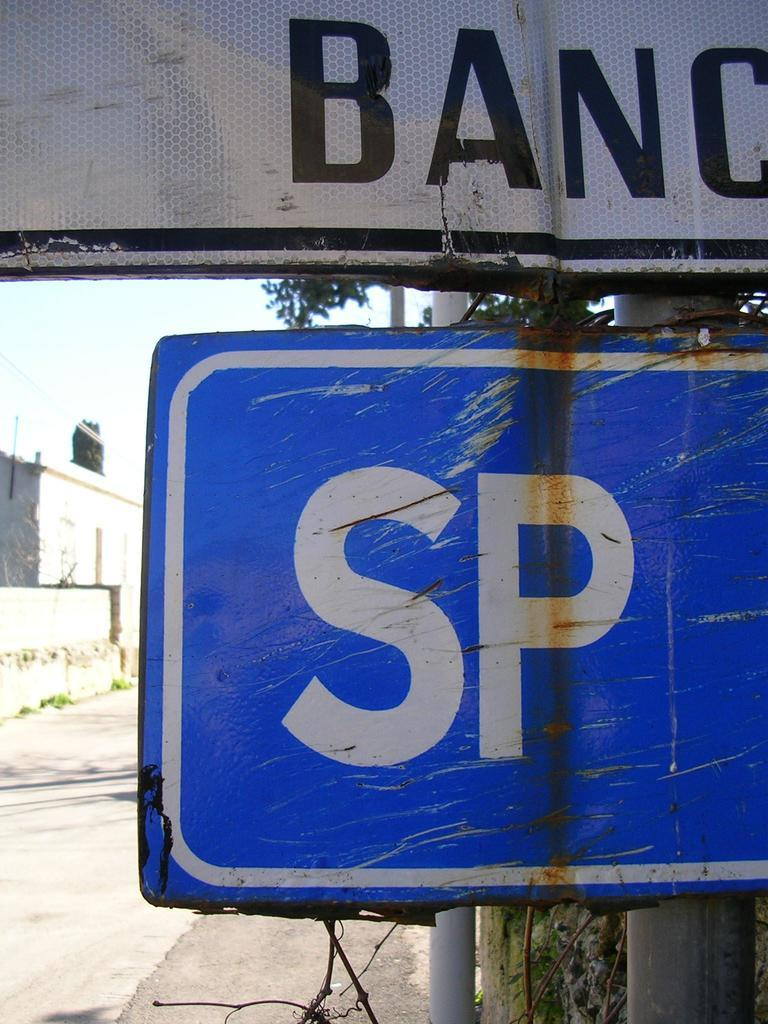Provide a one-sentence caption for the provided image. A white Blanc sign is above a SP sign. 